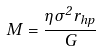<formula> <loc_0><loc_0><loc_500><loc_500>M = \frac { \eta \sigma ^ { 2 } r _ { h p } } { G }</formula> 